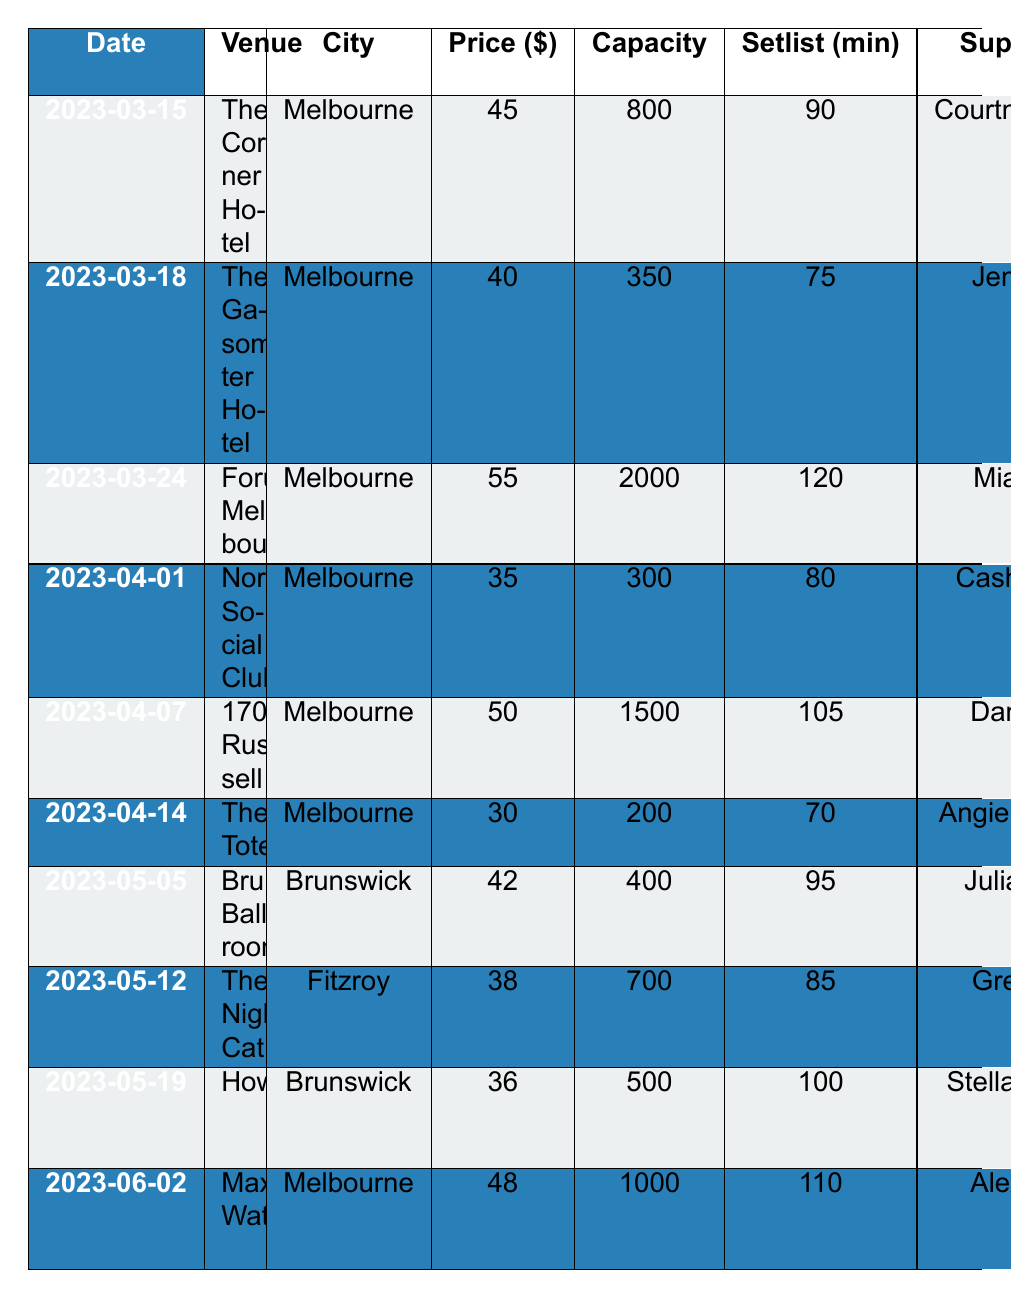What is the venue for the tour date on March 24, 2023? The table shows that on March 24, 2023, the venue is Forum Melbourne.
Answer: Forum Melbourne What is the ticket price for the show at The Tote? Looking at the table, the ticket price for the show at The Tote on April 14, 2023, is $30.
Answer: $30 Which city hosts the most tour dates? By checking the table, all the listed venues for the tour dates fall within Melbourne except for two in Brunswick and Fitzroy. Therefore, Melbourne has the most tour dates.
Answer: Melbourne Which support act is performing on the same date as Tim Rogers? The date when Tim Rogers is a special guest is April 7, and the support act on that date is Dan Sultan.
Answer: Dan Sultan What is the average ticket price for the shows in Melbourne? The ticket prices for shows in Melbourne are $45, $40, $55, $35, $50, $30, and $48. Summing these gives $45 + 40 + 55 + 35 + 50 + 30 + 48 = $303. There are 7 shows, so the average is $303/7 ≈ $43.29.
Answer: $43.29 Are there more shows with special guests than without? There are 10 total shows. Of those, 4 shows have special guests (Paul Kelly, Missy Higgins, Tim Rogers, and Kasey Chambers) while 6 do not. Since 4 < 6, there are more shows without special guests.
Answer: No What was the total capacity for all shows in Melbourne? The capacity for shows in Melbourne is 800, 350, 2000, 300, 1500, 200, and 1000. Adding these gives 800 + 350 + 2000 + 300 + 1500 + 200 + 1000 = 4250.
Answer: 4250 Which venue has the largest capacity and what is that capacity? Among the venues listed, Forum Melbourne has the largest capacity of 2000.
Answer: Forum Melbourne, 2000 How many performances included a setlist length of more than 100 minutes? The setlist lengths longer than 100 minutes are 120, 105, and 110. Therefore, there are 3 performances over 100 minutes.
Answer: 3 What is the total number of merchandise items available across all shows? The merchandise items listed are T-shirts, Vinyl, CDs, Posters, Tote bags, Hats, Stickers, Patches, Pins, and Keychains. Counting each unique merchandise item and their occurrences, we find that merchandise overlaps across shows, but each item type (like T-shirts, Vinyl, etc.) can be counted once. There are therefore 9 unique item types available.
Answer: 9 